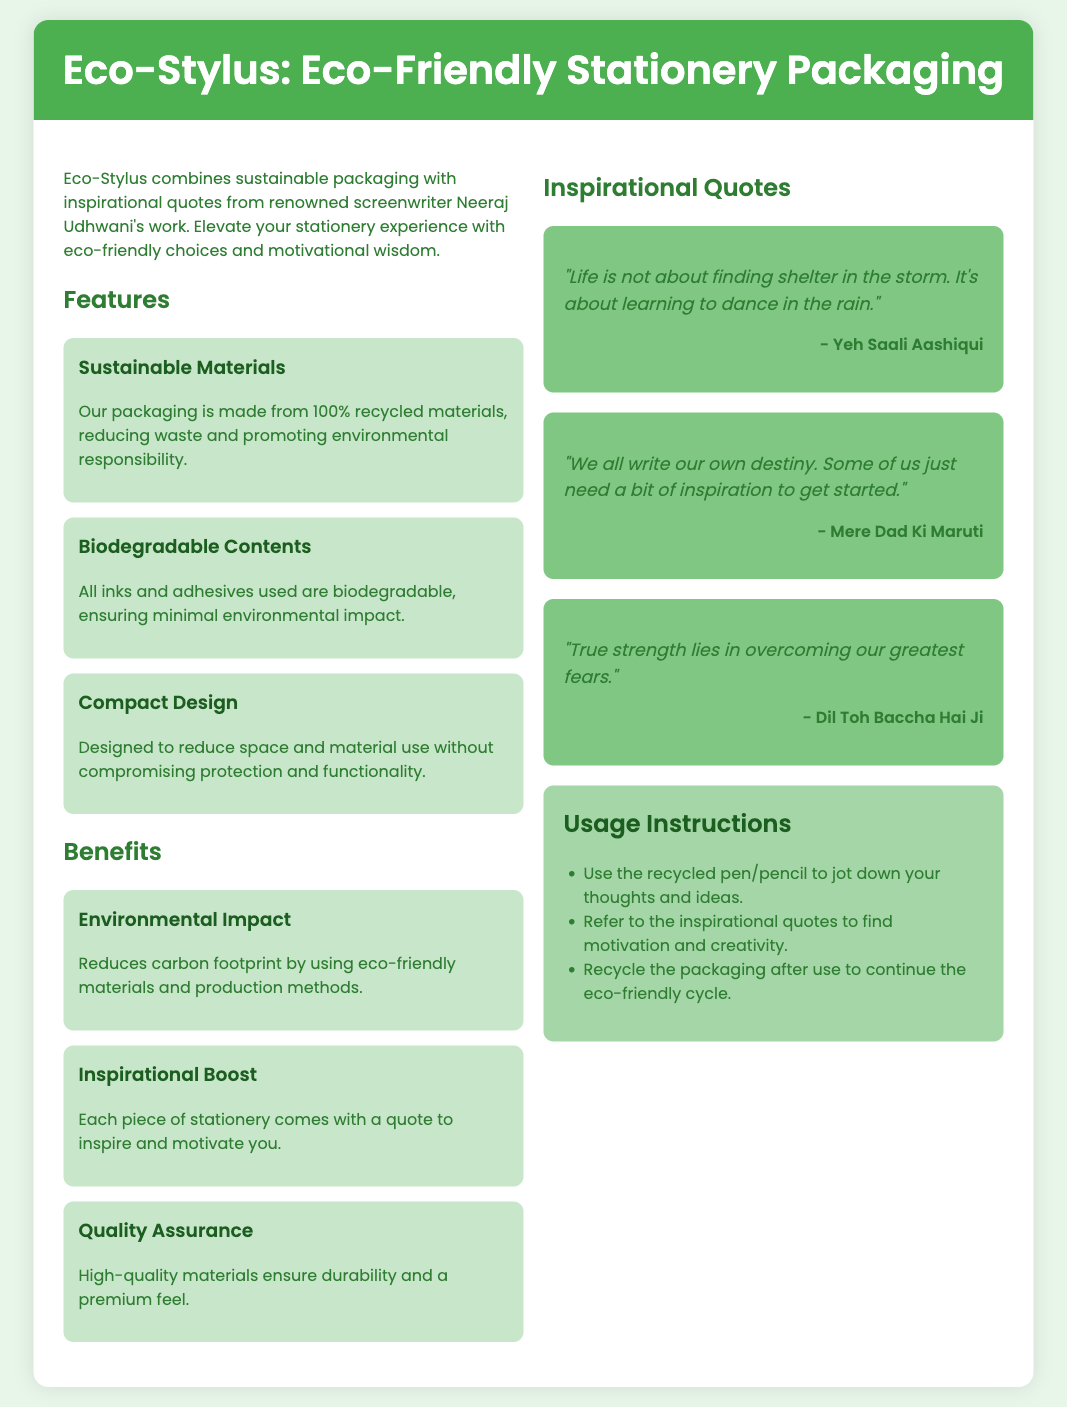What is the main theme of Eco-Stylus packaging? The document presents Eco-Stylus as combining sustainable packaging with inspirational quotes from Neeraj Udhwani's work.
Answer: Sustainable packaging and inspiration What materials are used in the packaging? The document states that the packaging is made from 100% recycled materials.
Answer: 100% recycled materials What type of inks are used in Eco-Stylus products? According to the document, all inks used are biodegradable, ensuring minimal environmental impact.
Answer: Biodegradable How many inspirational quotes are featured in the packaging? The document includes three quotes attributed to Neeraj Udhwani's screenplays.
Answer: Three What is the suggested usage of the recycled pen/pencil? The instructions indicate using the pen/pencil to jot down thoughts and ideas.
Answer: Jot down thoughts and ideas What screenplay does the quote about dancing in the rain come from? The document attributes the quote about finding shelter in the storm to the screenplay "Yeh Saali Aashiqui".
Answer: Yeh Saali Aashiqui What does the document suggest doing after using the packaging? The instructions recommend recycling the packaging after use.
Answer: Recycle the packaging What benefit is highlighted regarding the quality of materials? The document emphasizes that high-quality materials ensure durability and a premium feel.
Answer: Durability and premium feel 